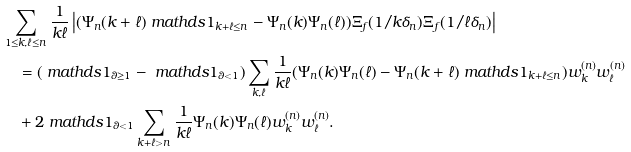<formula> <loc_0><loc_0><loc_500><loc_500>& \sum _ { 1 \leq k , \ell \leq n } \frac { 1 } { k \ell } \left | ( \Psi _ { n } ( k + \ell ) \ m a t h d s { 1 } _ { k + \ell \leq n } - \Psi _ { n } ( k ) \Psi _ { n } ( \ell ) ) \Xi _ { f } ( 1 / k \delta _ { n } ) \Xi _ { f } ( 1 / \ell \delta _ { n } ) \right | \\ & \quad = ( \ m a t h d s { 1 } _ { \theta \geq 1 } - \ m a t h d s { 1 } _ { \theta < 1 } ) \sum _ { k , \ell } \frac { 1 } { k \ell } ( \Psi _ { n } ( k ) \Psi _ { n } ( \ell ) - \Psi _ { n } ( k + \ell ) \ m a t h d s { 1 } _ { k + \ell \leq n } ) w _ { k } ^ { ( n ) } w _ { \ell } ^ { ( n ) } \\ & \quad + 2 \ m a t h d s { 1 } _ { \theta < 1 } \sum _ { k + \ell > n } \frac { 1 } { k \ell } \Psi _ { n } ( k ) \Psi _ { n } ( \ell ) w _ { k } ^ { ( n ) } w _ { \ell } ^ { ( n ) } .</formula> 